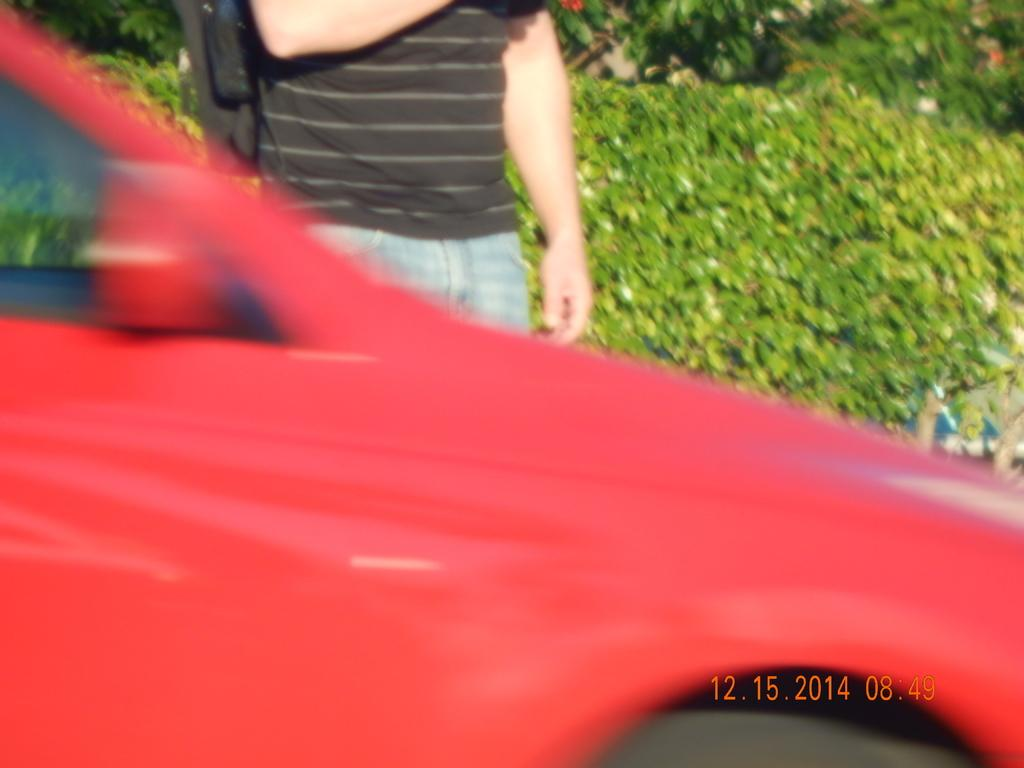What is the main subject in the image? There is a person standing in the image. What type of vehicle is visible in the image? There is a red color car in the image. Can you describe any additional features in the image? There is a watermark on the right side of the image, and plants can be seen in the background. What type of teaching is happening at the playground in the image? There is no playground or teaching activity present in the image. 